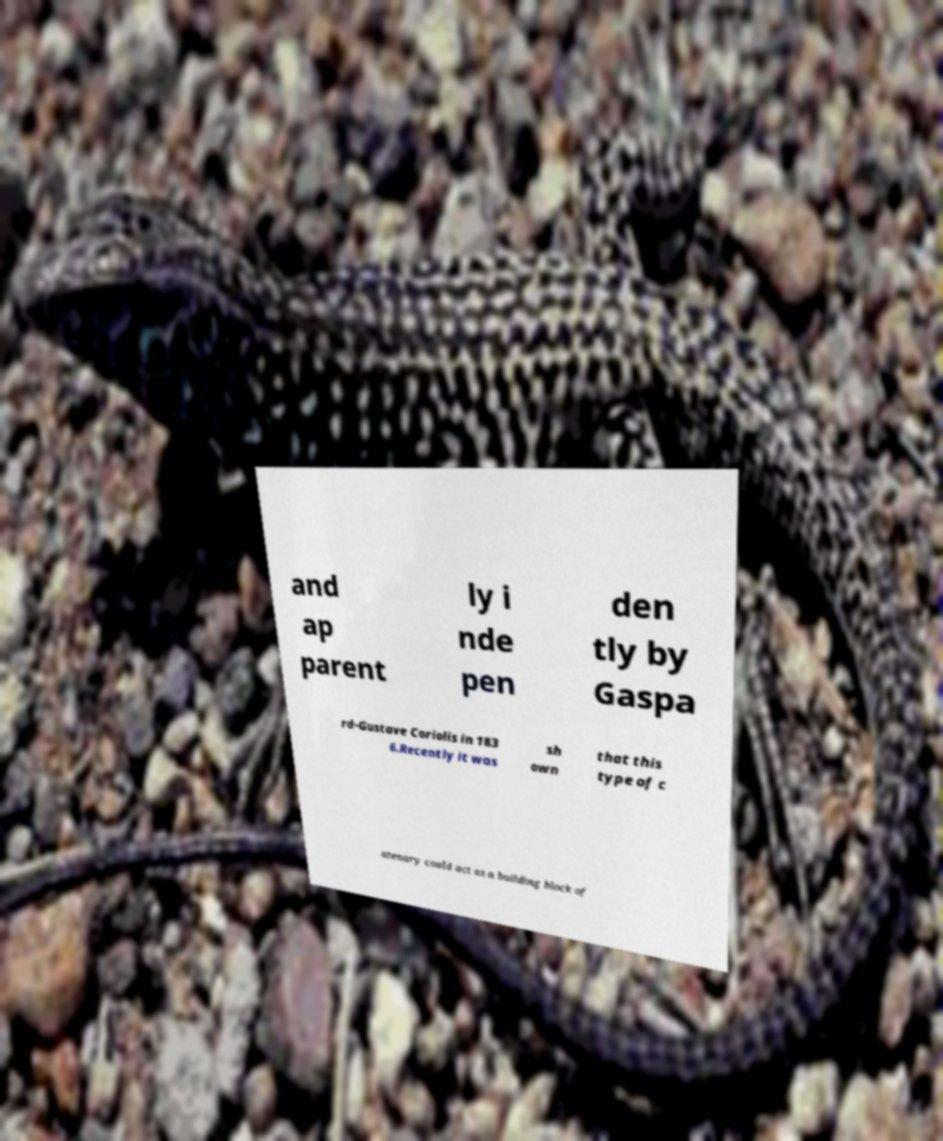Please read and relay the text visible in this image. What does it say? and ap parent ly i nde pen den tly by Gaspa rd-Gustave Coriolis in 183 6.Recently it was sh own that this type of c atenary could act as a building block of 